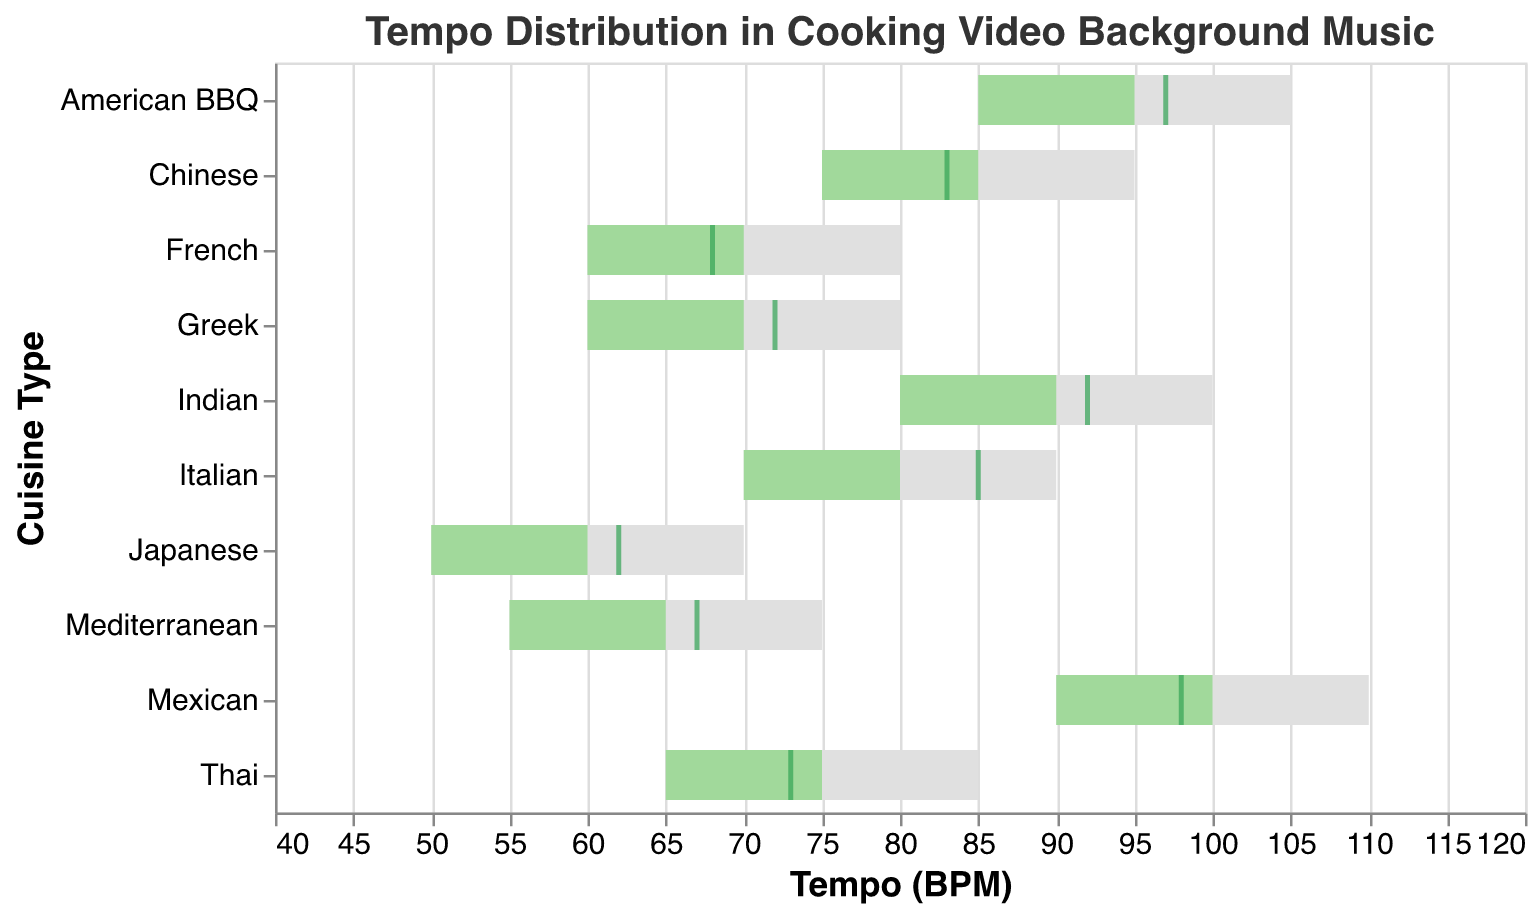What's the title of the chart? The title is usually displayed at the top of the chart. In this case, the title reads "Tempo Distribution in Cooking Video Background Music."
Answer: Tempo Distribution in Cooking Video Background Music Which cuisine has the highest target tempo? Examining the chart, the cuisine with the highest target tempo will have the farthest colored bar along the x-axis. In this case, Mexican cuisine has the highest target tempo of 100 BPM.
Answer: Mexican What is the actual tempo for Italian cuisine? Locate the tick mark that corresponds to the actual tempo for Italian cuisine; it is positioned at 85 BPM.
Answer: 85 BPM How many cuisines have an actual tempo higher than the target tempo? Compare the actual tempo tick mark with the target tempo end of the green bar for each cuisine. The cuisines where the tick mark is to the right of the end of the green bar have a higher actual tempo than the target tempo. In this case, Indian and Greek cuisines have higher actual tempos.
Answer: 2 Which cuisine has the smallest range in tempo? The range in tempo can be calculated by subtracting the range start from the range end for each cuisine. The smallest range is for Japanese cuisine (70 - 50 = 20).
Answer: Japanese What is the difference between the target and actual tempo for French cuisine? Subtract the actual tempo from the target tempo for French cuisine: 70 - 68 = 2 BPM.
Answer: 2 BPM Which cuisine's actual tempo is closest to its target tempo? Calculate the absolute difference between the actual and target tempos for each cuisine and find the smallest difference. The Mexican cuisine has the smallest difference of 2 BPM (100 - 98).
Answer: Mexican For which cuisine is the actual tempo outside the target tempo range? Check if the tick mark for actual tempo falls outside the gray bar that represents the target tempo range. In this case, no cuisine has an actual tempo outside the target range.
Answer: None What is the average target tempo across all cuisines? Sum all the target tempos and divide by the number of cuisines. The sum of target tempos is 785, divided by 10 cuisines, resulting in an average target tempo of 78.5 BPM.
Answer: 78.5 BPM Which cuisine has both target and actual tempos within its range? Check the cuisines where the target and actual tempo bars and ticks fall within the gray bar that represents the tempo range. In this case, all cuisines have both target and actual tempos within their respective ranges.
Answer: All 